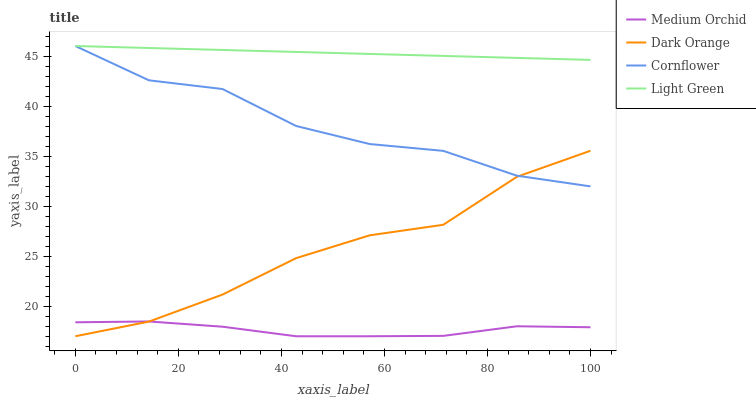Does Medium Orchid have the minimum area under the curve?
Answer yes or no. Yes. Does Light Green have the minimum area under the curve?
Answer yes or no. No. Does Medium Orchid have the maximum area under the curve?
Answer yes or no. No. Is Medium Orchid the smoothest?
Answer yes or no. No. Is Medium Orchid the roughest?
Answer yes or no. No. Does Light Green have the lowest value?
Answer yes or no. No. Does Medium Orchid have the highest value?
Answer yes or no. No. Is Medium Orchid less than Light Green?
Answer yes or no. Yes. Is Cornflower greater than Medium Orchid?
Answer yes or no. Yes. Does Medium Orchid intersect Light Green?
Answer yes or no. No. 